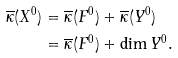Convert formula to latex. <formula><loc_0><loc_0><loc_500><loc_500>\overline { \kappa } ( X ^ { 0 } ) & = \overline { \kappa } ( F ^ { 0 } ) + \overline { \kappa } ( Y ^ { 0 } ) \\ & = \overline { \kappa } ( F ^ { 0 } ) + \dim Y ^ { 0 } .</formula> 